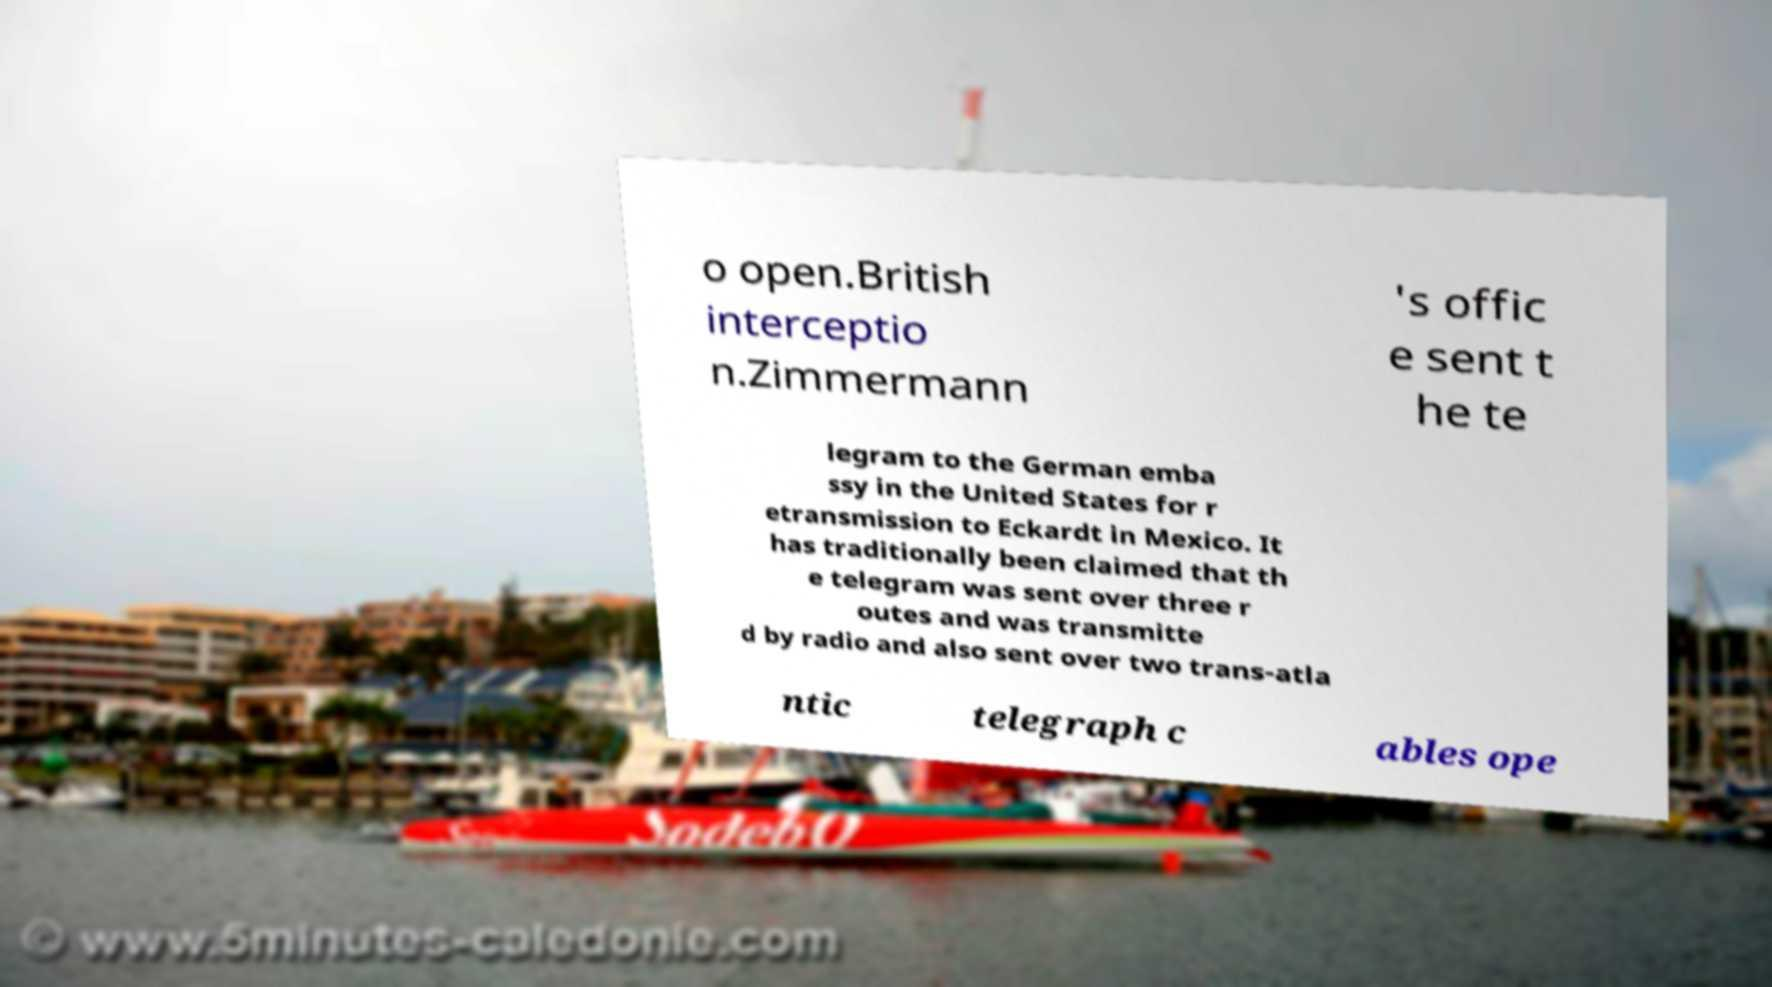Please read and relay the text visible in this image. What does it say? o open.British interceptio n.Zimmermann 's offic e sent t he te legram to the German emba ssy in the United States for r etransmission to Eckardt in Mexico. It has traditionally been claimed that th e telegram was sent over three r outes and was transmitte d by radio and also sent over two trans-atla ntic telegraph c ables ope 